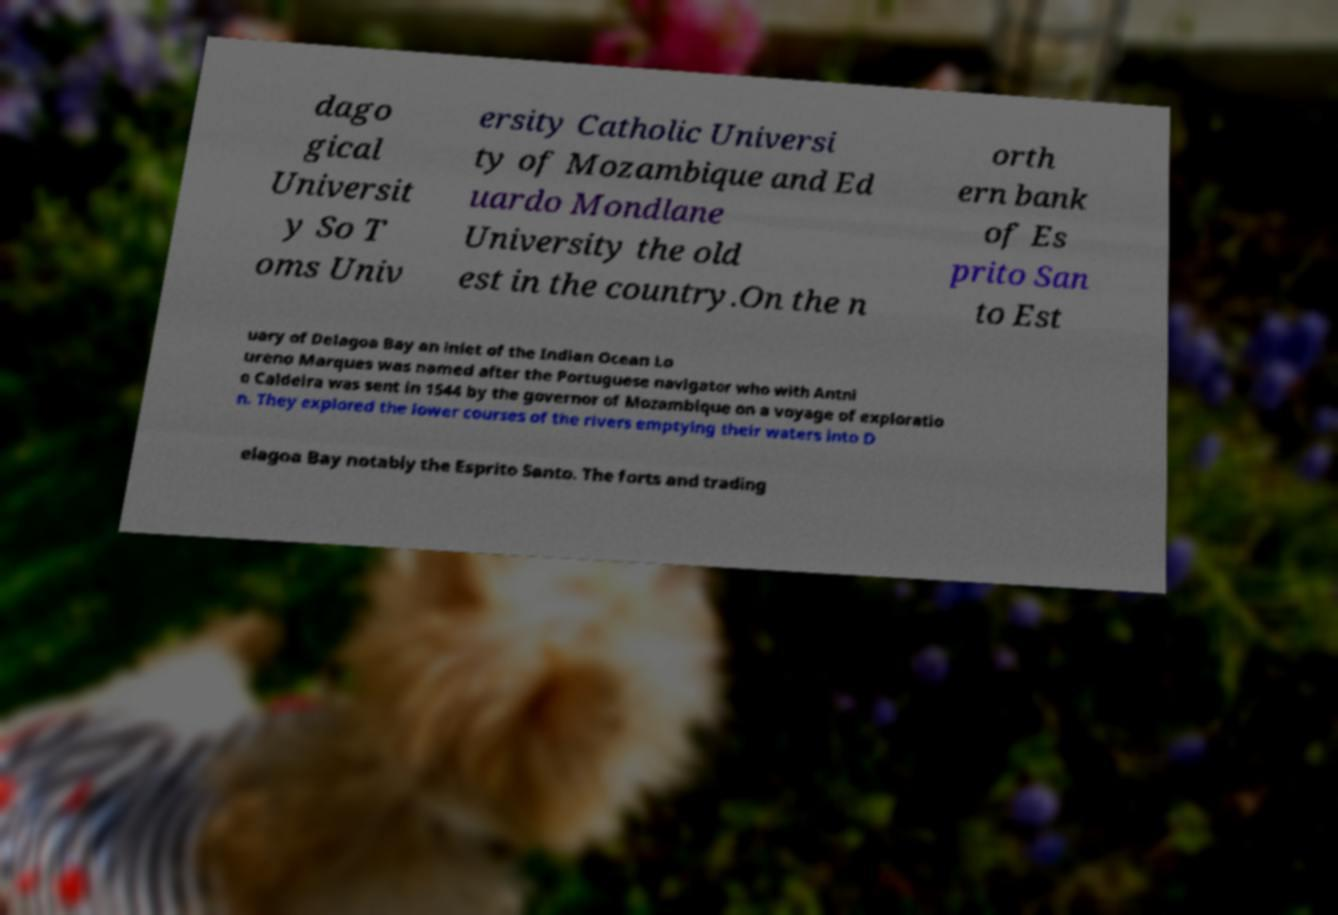Can you read and provide the text displayed in the image?This photo seems to have some interesting text. Can you extract and type it out for me? dago gical Universit y So T oms Univ ersity Catholic Universi ty of Mozambique and Ed uardo Mondlane University the old est in the country.On the n orth ern bank of Es prito San to Est uary of Delagoa Bay an inlet of the Indian Ocean Lo ureno Marques was named after the Portuguese navigator who with Antni o Caldeira was sent in 1544 by the governor of Mozambique on a voyage of exploratio n. They explored the lower courses of the rivers emptying their waters into D elagoa Bay notably the Esprito Santo. The forts and trading 